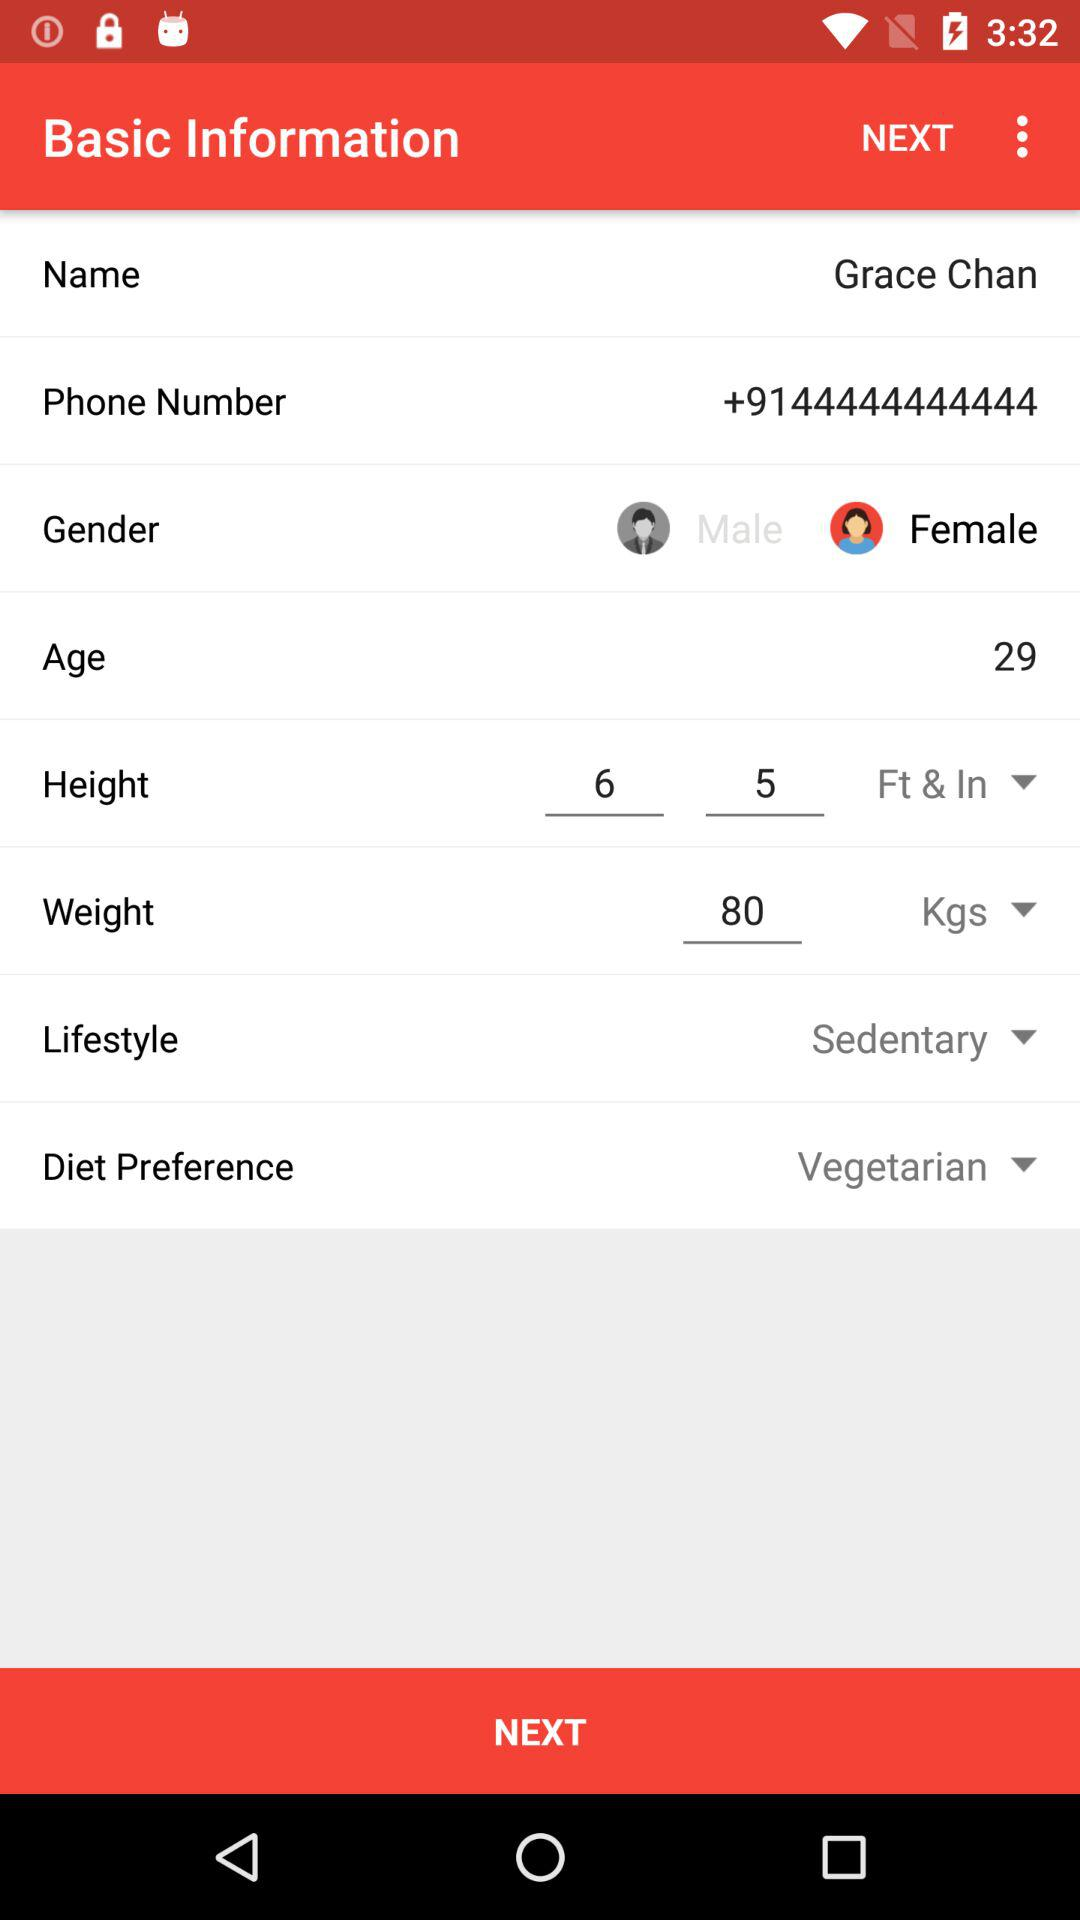What is the height of the user? The height of the user is 6 feet 5 inches. 